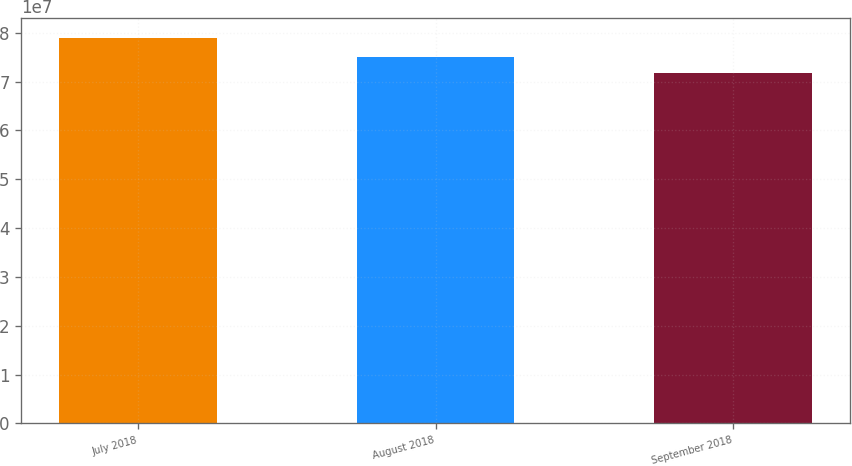Convert chart. <chart><loc_0><loc_0><loc_500><loc_500><bar_chart><fcel>July 2018<fcel>August 2018<fcel>September 2018<nl><fcel>7.89902e+07<fcel>7.5055e+07<fcel>7.17349e+07<nl></chart> 